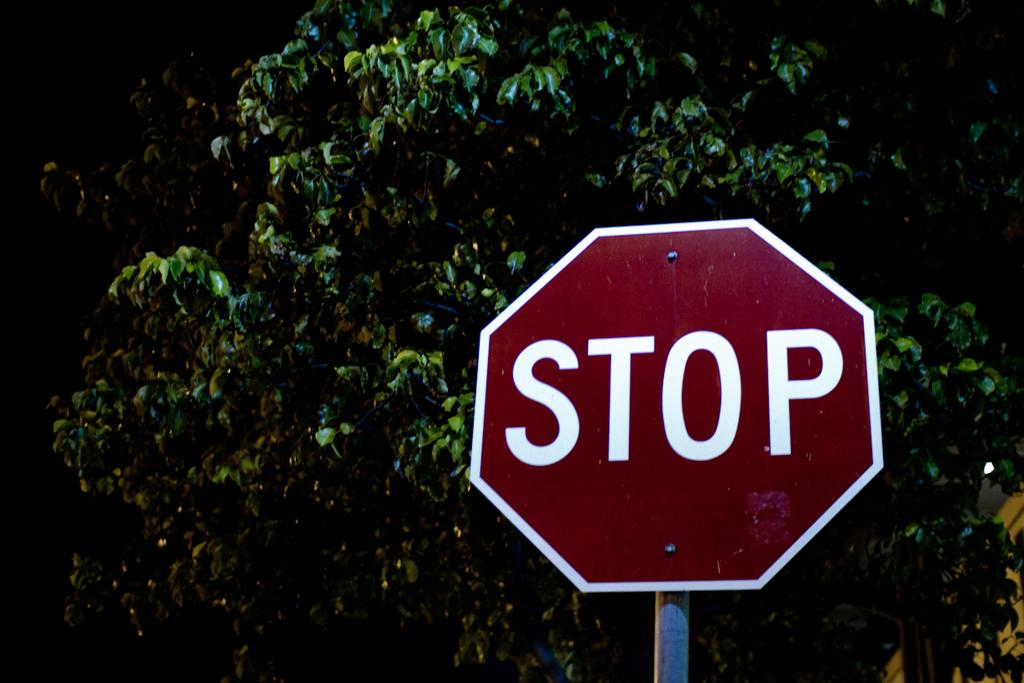<image>
Relay a brief, clear account of the picture shown. A red and white stop sign in front of a tree. 